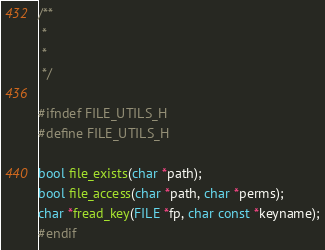Convert code to text. <code><loc_0><loc_0><loc_500><loc_500><_C_>/**
 * 
 * 
 */

#ifndef FILE_UTILS_H
#define FILE_UTILS_H

bool file_exists(char *path);
bool file_access(char *path, char *perms);
char *fread_key(FILE *fp, char const *keyname);
#endif
</code> 